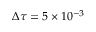<formula> <loc_0><loc_0><loc_500><loc_500>\Delta \tau = 5 \times 1 0 ^ { - 3 }</formula> 